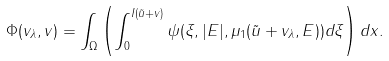<formula> <loc_0><loc_0><loc_500><loc_500>\Phi ( v _ { \lambda } , v ) = \int _ { \Omega } \left ( \int _ { 0 } ^ { I ( \tilde { u } + v ) } \psi ( \xi , | E | , \mu _ { 1 } ( \tilde { u } + v _ { \lambda } , E ) ) d \xi \right ) d x .</formula> 